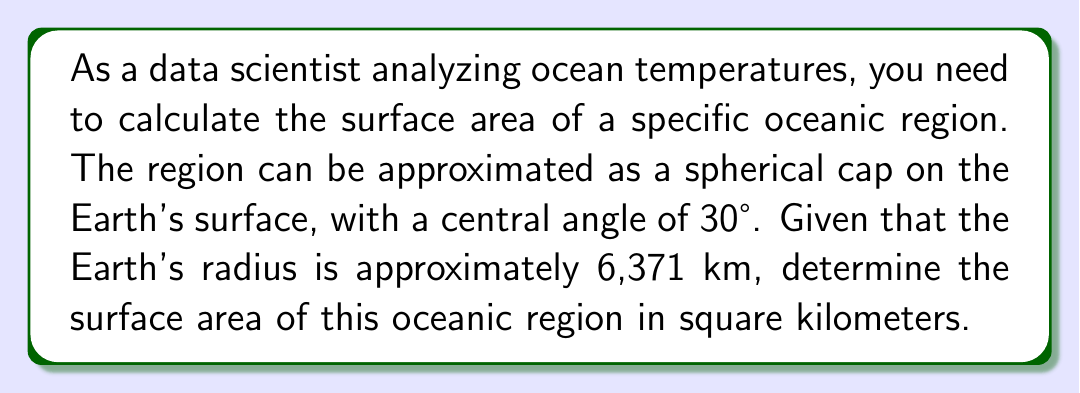Help me with this question. To solve this problem, we'll use the formula for the surface area of a spherical cap:

$$A = 2\pi R h$$

Where:
$A$ is the surface area of the spherical cap
$R$ is the radius of the sphere (Earth in this case)
$h$ is the height of the spherical cap

Step 1: Calculate the height of the spherical cap
The height of a spherical cap can be calculated using the formula:

$$h = R(1 - \cos\theta)$$

Where $\theta$ is half of the central angle.

In this case, $\theta = 15°$ (half of 30°)

$$h = 6371 \cdot (1 - \cos 15°)$$
$$h = 6371 \cdot (1 - 0.9659) \approx 218.24 \text{ km}$$

Step 2: Calculate the surface area
Now we can use the surface area formula:

$$A = 2\pi R h$$
$$A = 2\pi \cdot 6371 \cdot 218.24$$
$$A \approx 8,731,582 \text{ km}^2$$

[asy]
import geometry;

size(200);
draw(circle((0,0),1));
draw((-1,0)--(1,0));
draw((0,0)--(cos(75°),sin(75°)));
draw((0,0)--(cos(105°),sin(105°)));
label("30°", (0.2,0.1));
label("R", (0.5,-0.1));
label("h", (-0.1,0.5));
[/asy]
Answer: 8,731,582 km² 